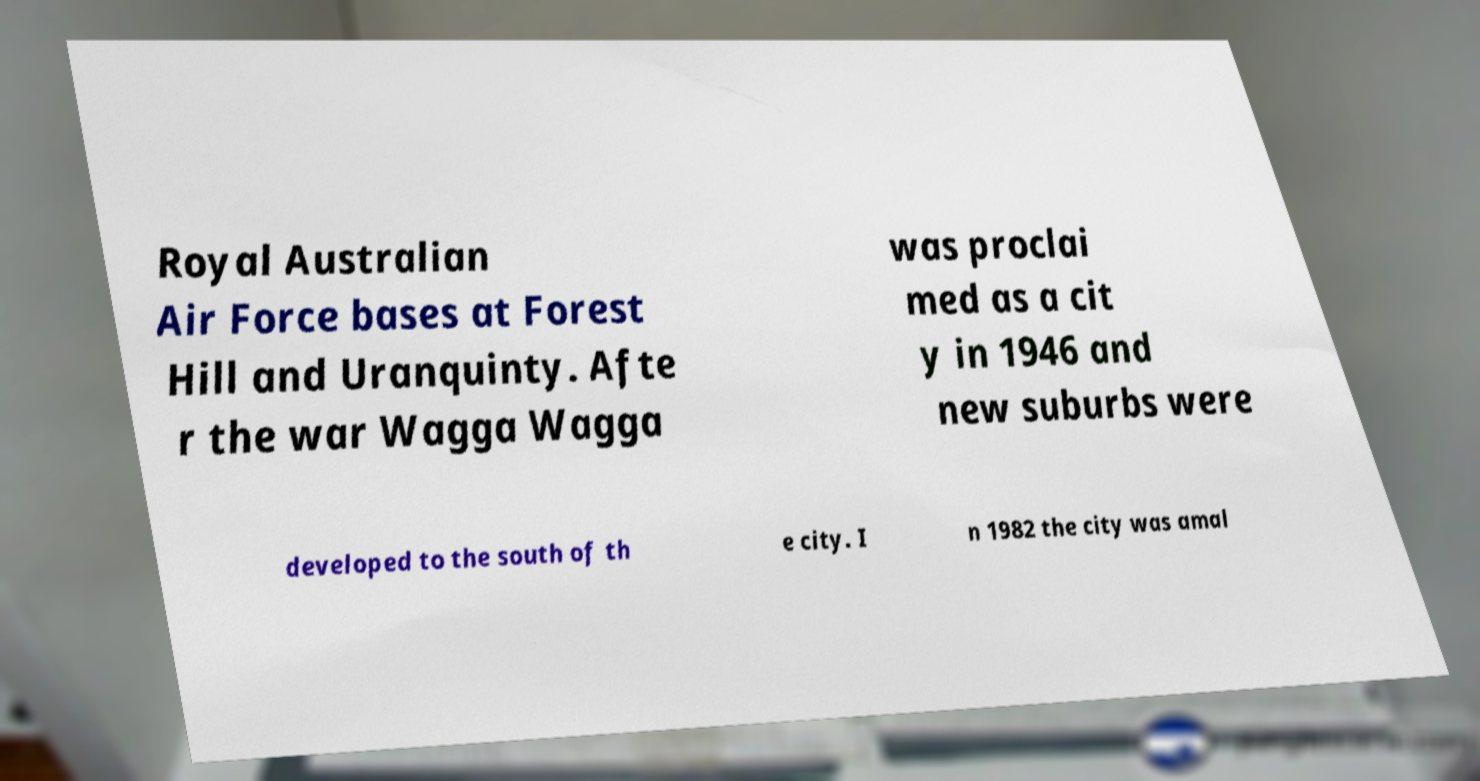There's text embedded in this image that I need extracted. Can you transcribe it verbatim? Royal Australian Air Force bases at Forest Hill and Uranquinty. Afte r the war Wagga Wagga was proclai med as a cit y in 1946 and new suburbs were developed to the south of th e city. I n 1982 the city was amal 